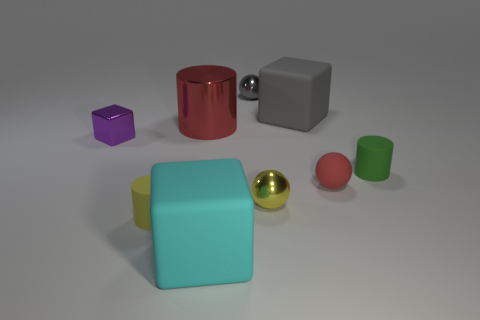What number of small red objects have the same shape as the gray matte thing?
Provide a short and direct response. 0. Are the purple cube and the tiny cylinder on the left side of the tiny matte sphere made of the same material?
Provide a short and direct response. No. There is a yellow thing that is the same material as the purple block; what is its size?
Provide a succinct answer. Small. What is the size of the matte cube in front of the shiny block?
Ensure brevity in your answer.  Large. How many metallic cubes are the same size as the green matte cylinder?
Your answer should be compact. 1. There is a rubber sphere that is the same color as the big shiny cylinder; what size is it?
Make the answer very short. Small. Are there any matte cubes that have the same color as the metal cylinder?
Offer a terse response. No. There is a cube that is the same size as the green matte thing; what color is it?
Your answer should be very brief. Purple. There is a tiny metallic block; is its color the same as the rubber cylinder to the left of the green rubber thing?
Provide a succinct answer. No. What is the color of the small metal cube?
Ensure brevity in your answer.  Purple. 